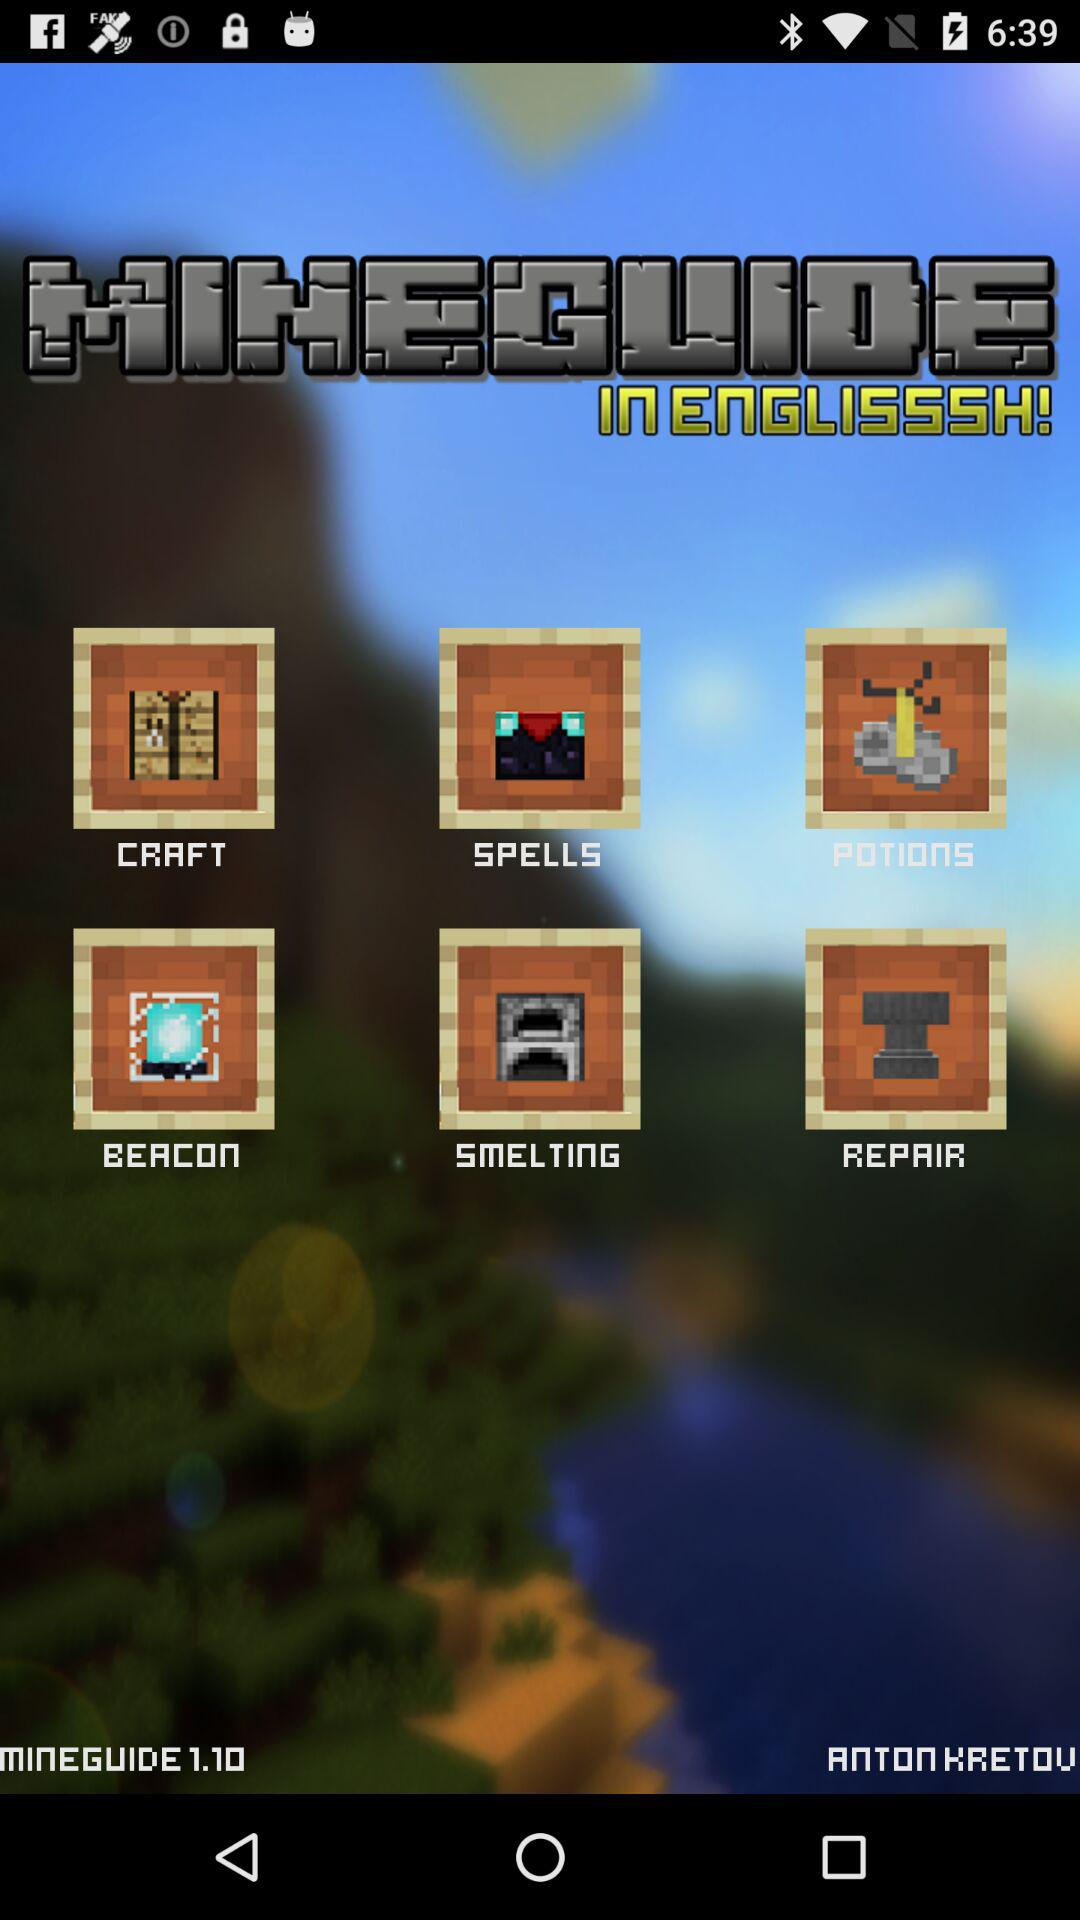How many items are there in the app?
Answer the question using a single word or phrase. 6 